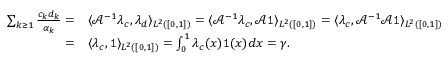Convert formula to latex. <formula><loc_0><loc_0><loc_500><loc_500>\begin{array} { r l } { \sum _ { k \geq 1 } \frac { c _ { k } d _ { k } } { \alpha _ { k } } = } & { \langle \mathcal { A } ^ { - 1 } \lambda _ { c } , \lambda _ { d } \rangle _ { L ^ { 2 } ( [ 0 , 1 ] ) } = \langle \mathcal { A } ^ { - 1 } \lambda _ { c } , \mathcal { A } 1 \rangle _ { L ^ { 2 } ( [ 0 , 1 ] ) } = \langle \lambda _ { c } , \mathcal { A } ^ { - 1 } \mathcal { A } 1 \rangle _ { L ^ { 2 } ( [ 0 , 1 ] ) } } \\ { = } & { \langle \lambda _ { c } , 1 \rangle _ { L ^ { 2 } ( [ 0 , 1 ] ) } = \int _ { 0 } ^ { 1 } \lambda _ { c } ( x ) 1 ( x ) d x = \gamma . } \end{array}</formula> 